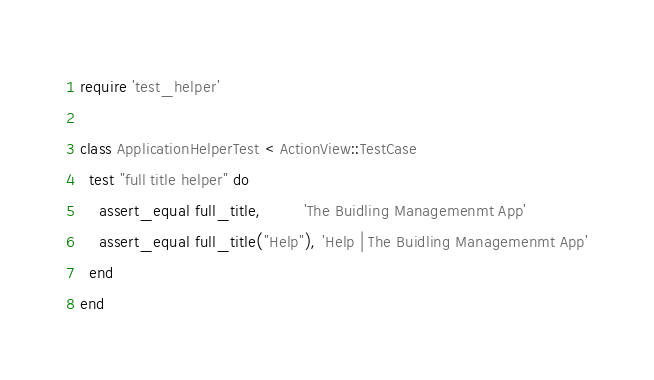Convert code to text. <code><loc_0><loc_0><loc_500><loc_500><_Ruby_>require 'test_helper'

class ApplicationHelperTest < ActionView::TestCase
  test "full title helper" do
    assert_equal full_title,         'The Buidling Managemenmt App'
    assert_equal full_title("Help"), 'Help | The Buidling Managemenmt App'
  end
end</code> 